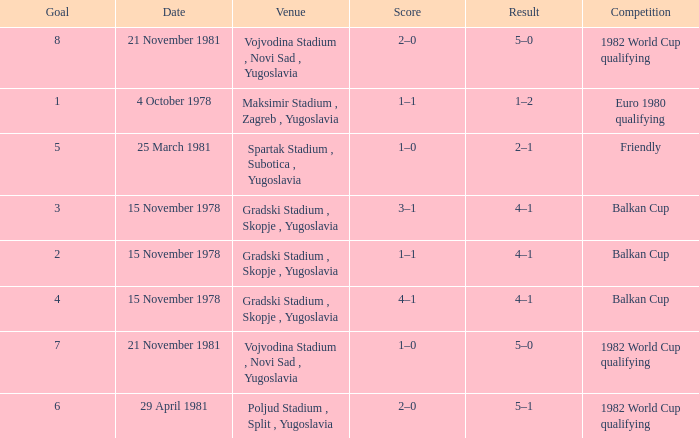What is the achievement for goal 3? 4–1. 